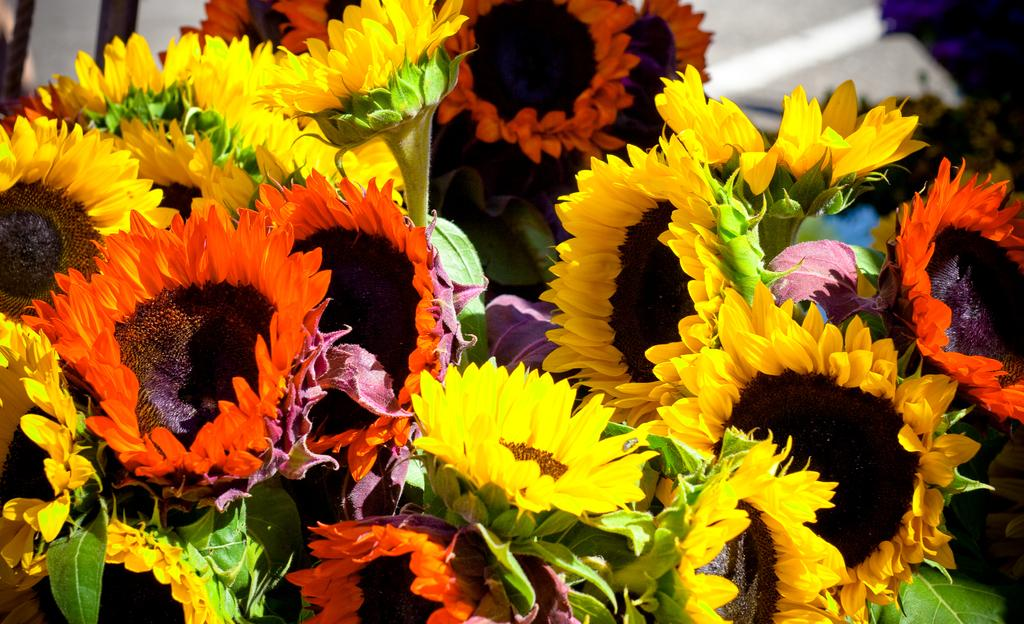What type of flowers are in the image? There are sunflowers in the image. What colors can be seen on the sunflowers? The sunflowers have orange and yellow colors. What type of pet can be seen playing with a cord in the image? There is no pet or cord present in the image; it features sunflowers with orange and yellow colors. 